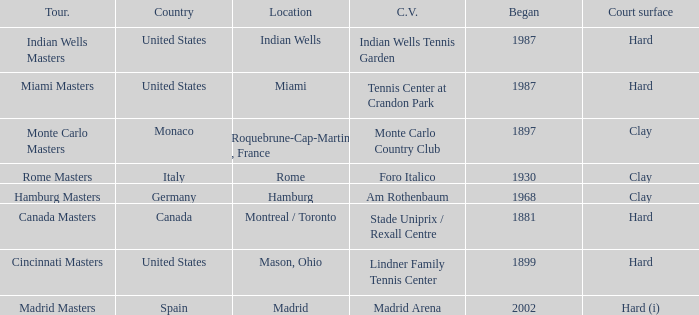Which current venues location is Mason, Ohio? Lindner Family Tennis Center. 